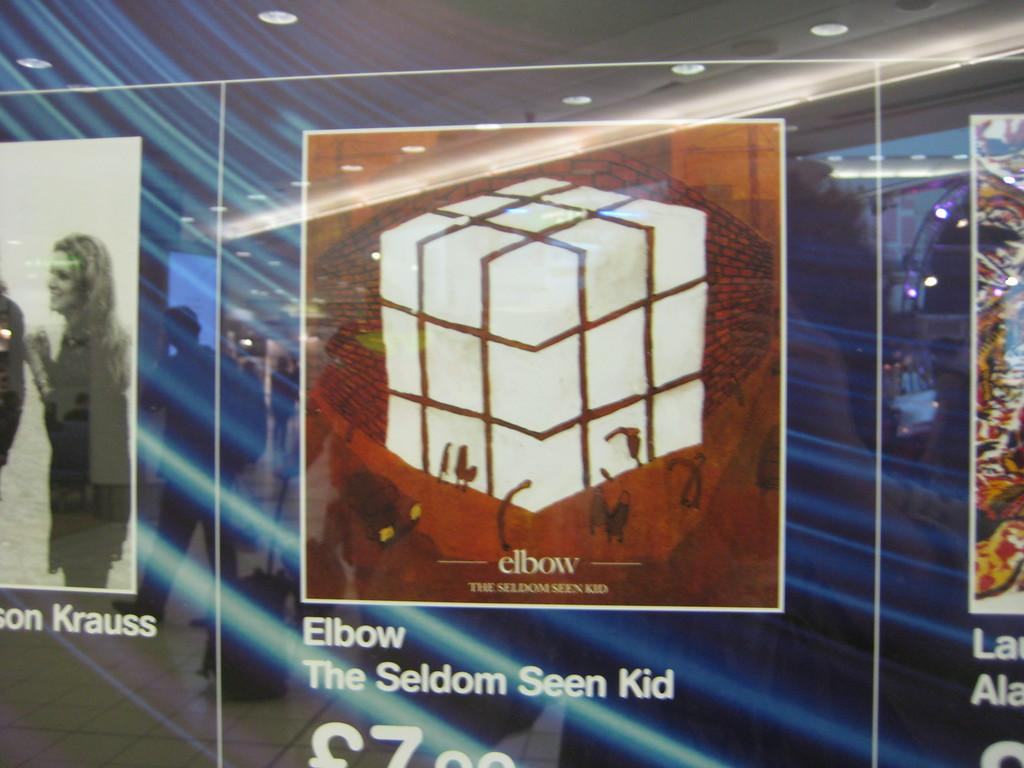<image>
Present a compact description of the photo's key features. An image of a cube that says "elbow, the seldom seen kid." 